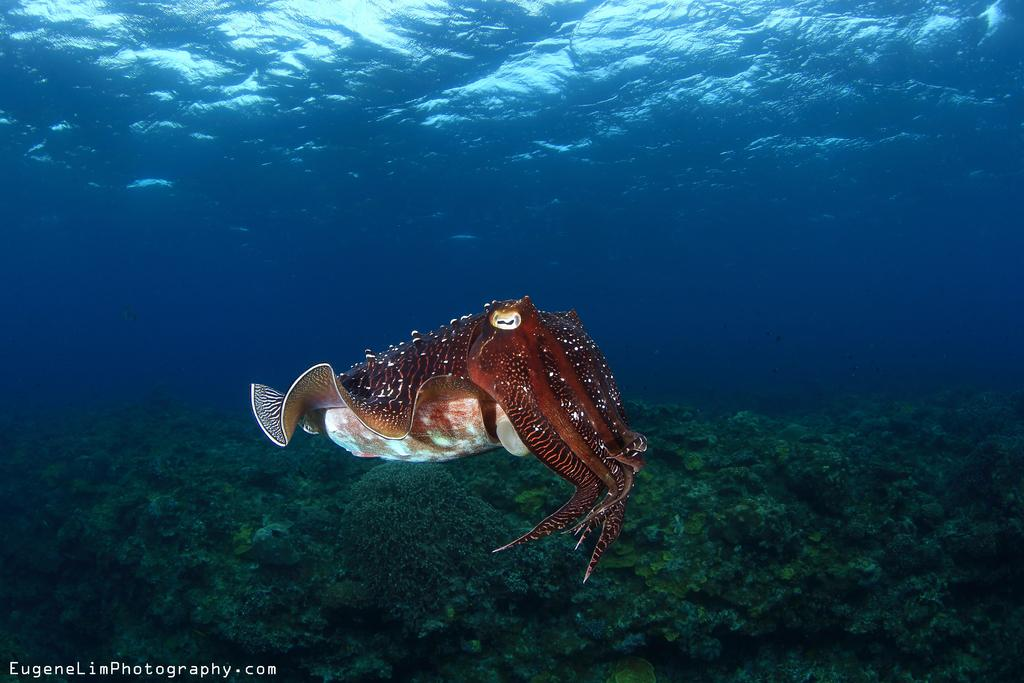What type of sea creature is in the image? There is an octopus in the image. What color is the octopus? The octopus is brown in color. What is present at the bottom of the image? There is plankton at the bottom of the image. What type of environment is depicted in the image? The image contains water, suggesting it is an underwater scene. Where are the children playing on the hill in the image? There are no children or hills present in the image; it features an octopus and plankton in an underwater environment. 